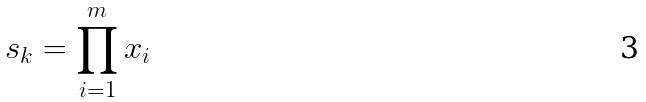<formula> <loc_0><loc_0><loc_500><loc_500>s _ { k } = \prod _ { i = 1 } ^ { m } x _ { i }</formula> 